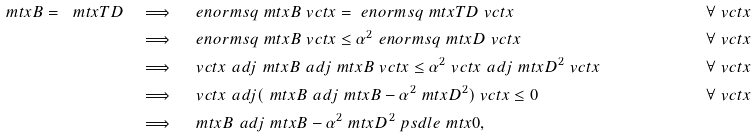<formula> <loc_0><loc_0><loc_500><loc_500>\ m t x { B } = \ m t x { T D } & \quad \Longrightarrow \quad \ e n o r m s q { \ m t x { B } \ v c t { x } } = \ e n o r m s q { \ m t x { T D } \ v c t { x } } & \forall \ v c t { x } \\ & \quad \Longrightarrow \quad \ e n o r m s q { \ m t x { B } \ v c t { x } } \leq \alpha ^ { 2 } \ e n o r m s q { \ m t x { D } \ v c t { x } } & \forall \ v c t { x } \\ & \quad \Longrightarrow \quad \ v c t { x } ^ { \ } a d j \ m t x { B } ^ { \ } a d j \ m t x { B } \ v c t { x } \leq \alpha ^ { 2 } \ v c t { x } ^ { \ } a d j \ m t x { D } ^ { 2 } \ v c t { x } & \forall \ v c t { x } \\ & \quad \Longrightarrow \quad \ v c t { x } ^ { \ } a d j ( \ m t x { B } ^ { \ } a d j \ m t x { B } - \alpha ^ { 2 } \ m t x { D } ^ { 2 } ) \ v c t { x } \leq 0 & \forall \ v c t { x } \\ & \quad \Longrightarrow \quad \ m t x { B } ^ { \ } a d j \ m t x { B } - \alpha ^ { 2 } \ m t x { D } ^ { 2 } \ p s d l e \ m t x { 0 } ,</formula> 